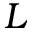<formula> <loc_0><loc_0><loc_500><loc_500>L</formula> 